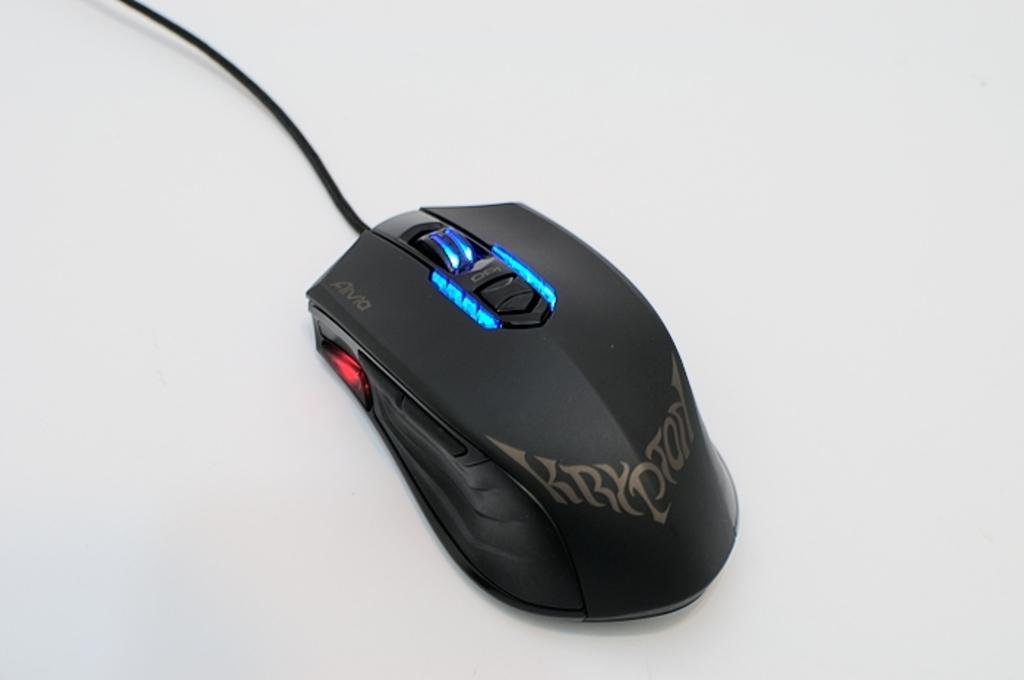<image>
Create a compact narrative representing the image presented. a digital mouse with the word krypton on it 